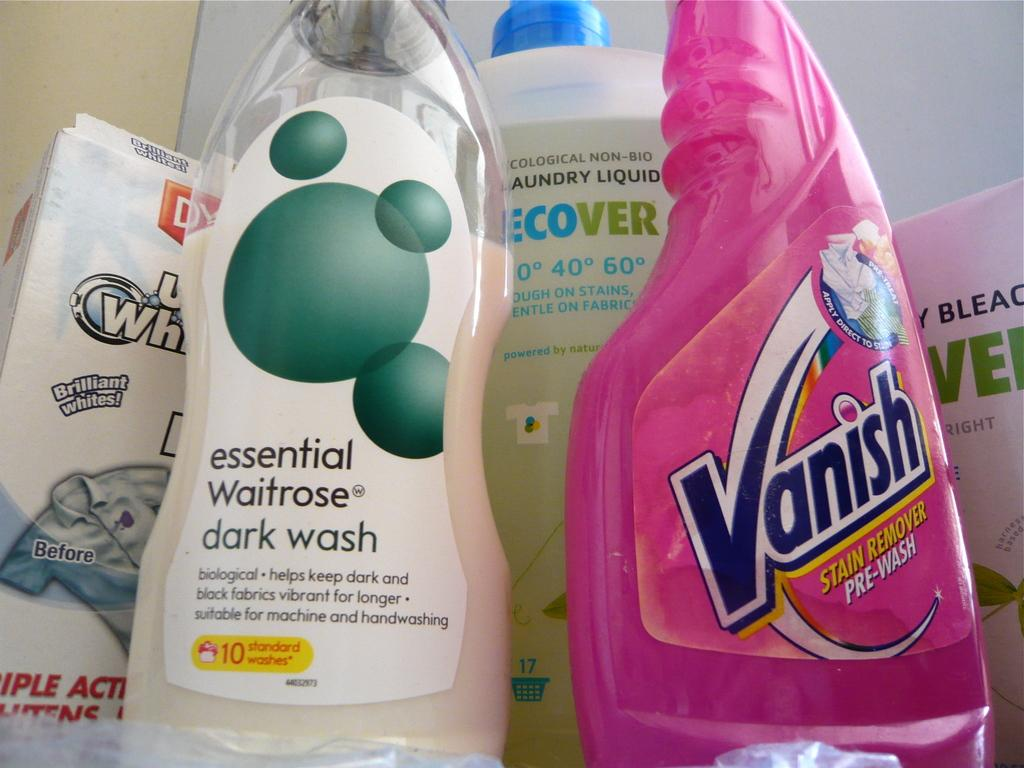Provide a one-sentence caption for the provided image. A bottle of Vanish sitting next to a bottle of Waitrose dark wash. 